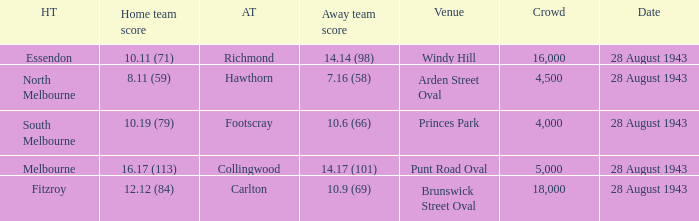Where was the game played with an away team score of 14.17 (101)? Punt Road Oval. 